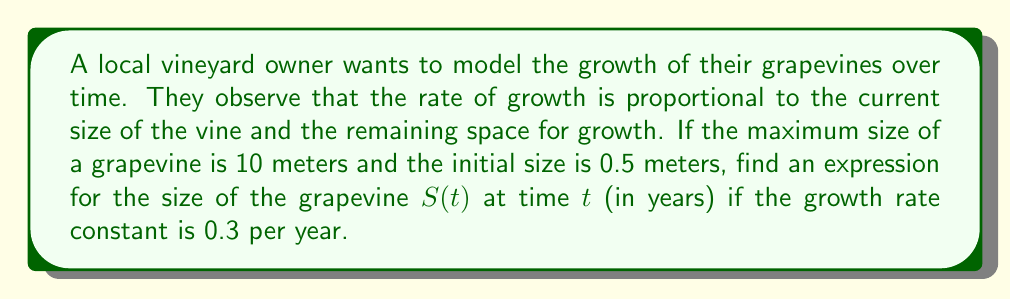Help me with this question. 1. Let's define our differential equation based on the given information:
   $$\frac{dS}{dt} = kS(10-S)$$
   where $k = 0.3$ is the growth rate constant, and 10 is the maximum size.

2. This is a logistic growth model. To solve it, we can use separation of variables:
   $$\frac{dS}{S(10-S)} = 0.3dt$$

3. Integrate both sides:
   $$\int \frac{dS}{S(10-S)} = \int 0.3dt$$

4. The left-hand side can be integrated using partial fractions:
   $$\frac{1}{10}\ln\left|\frac{S}{10-S}\right| = 0.3t + C$$

5. Solve for $S$:
   $$\frac{S}{10-S} = Ae^{3t}$$
   where $A = e^{10C}$

6. Rearrange to get $S$ in terms of $t$:
   $$S = \frac{10Ae^{3t}}{1+Ae^{3t}}$$

7. Use the initial condition $S(0) = 0.5$ to find $A$:
   $$0.5 = \frac{10A}{1+A}$$
   $$A = \frac{1}{19}$$

8. Substitute this value of $A$ back into our equation for $S(t)$:
   $$S(t) = \frac{10\cdot\frac{1}{19}e^{3t}}{1+\frac{1}{19}e^{3t}}$$

9. Simplify:
   $$S(t) = \frac{10e^{3t}}{19+e^{3t}}$$
Answer: $S(t) = \frac{10e^{3t}}{19+e^{3t}}$ 